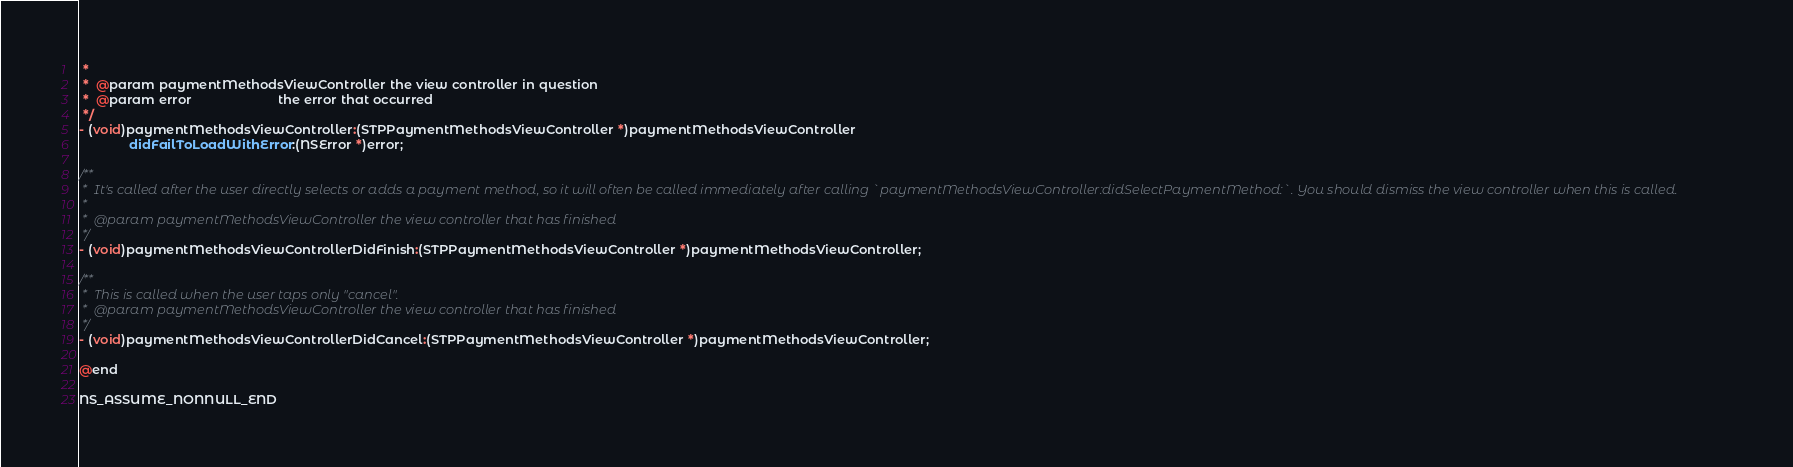Convert code to text. <code><loc_0><loc_0><loc_500><loc_500><_C_> *
 *  @param paymentMethodsViewController the view controller in question
 *  @param error                        the error that occurred
 */
- (void)paymentMethodsViewController:(STPPaymentMethodsViewController *)paymentMethodsViewController
              didFailToLoadWithError:(NSError *)error;

/**
 *  It's called after the user directly selects or adds a payment method, so it will often be called immediately after calling `paymentMethodsViewController:didSelectPaymentMethod:`. You should dismiss the view controller when this is called.
 *
 *  @param paymentMethodsViewController the view controller that has finished
 */
- (void)paymentMethodsViewControllerDidFinish:(STPPaymentMethodsViewController *)paymentMethodsViewController;

/**
 *  This is called when the user taps only "cancel".
 *  @param paymentMethodsViewController the view controller that has finished
 */
- (void)paymentMethodsViewControllerDidCancel:(STPPaymentMethodsViewController *)paymentMethodsViewController;

@end

NS_ASSUME_NONNULL_END
</code> 